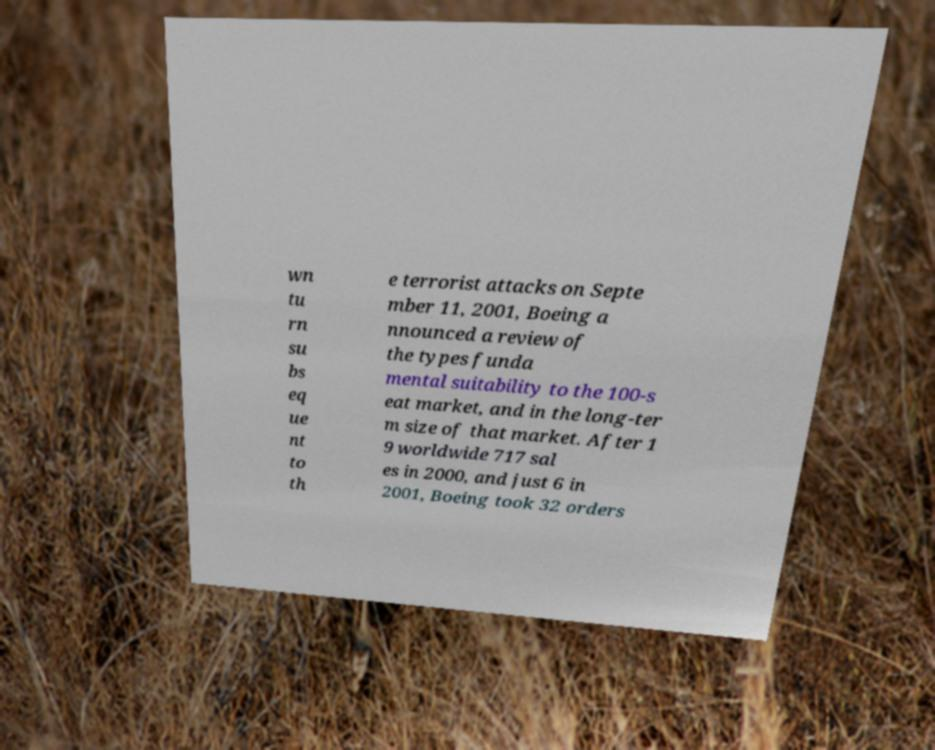Please read and relay the text visible in this image. What does it say? wn tu rn su bs eq ue nt to th e terrorist attacks on Septe mber 11, 2001, Boeing a nnounced a review of the types funda mental suitability to the 100-s eat market, and in the long-ter m size of that market. After 1 9 worldwide 717 sal es in 2000, and just 6 in 2001, Boeing took 32 orders 